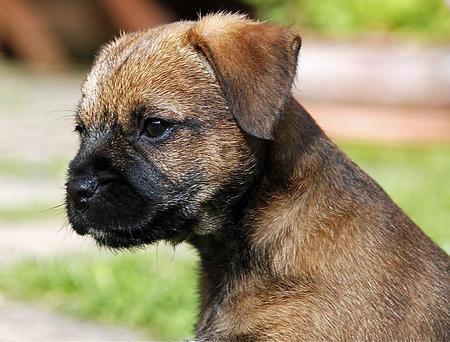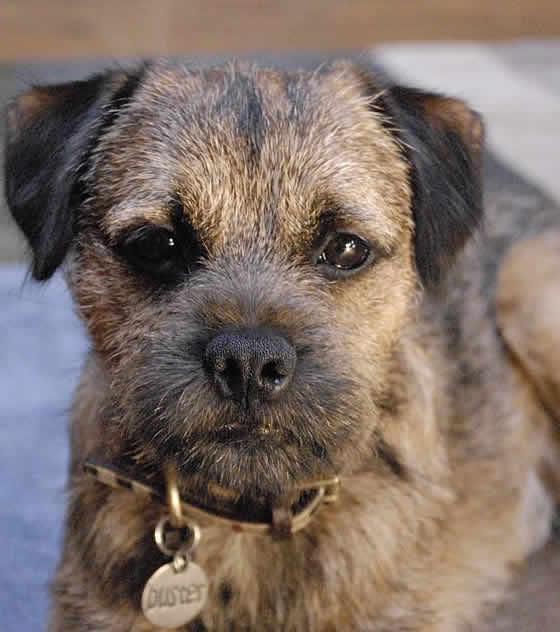The first image is the image on the left, the second image is the image on the right. Considering the images on both sides, is "There are two dogs wearing a collar." valid? Answer yes or no. No. 